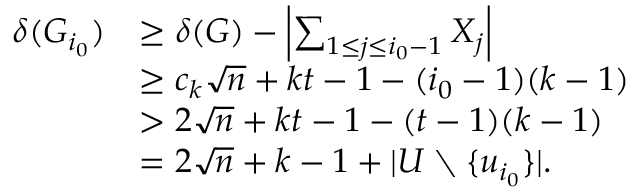<formula> <loc_0><loc_0><loc_500><loc_500>\begin{array} { r l } { \delta ( G _ { i _ { 0 } } ) } & { \geq \delta ( G ) - \left | \sum _ { 1 \leq j \leq i _ { 0 } - 1 } X _ { j } \right | } \\ & { \geq c _ { k } \sqrt { n } + k t - 1 - ( i _ { 0 } - 1 ) ( k - 1 ) } \\ & { > 2 \sqrt { n } + k t - 1 - ( t - 1 ) ( k - 1 ) } \\ & { = 2 \sqrt { n } + k - 1 + | U \ \{ u _ { i _ { 0 } } \} | . } \end{array}</formula> 